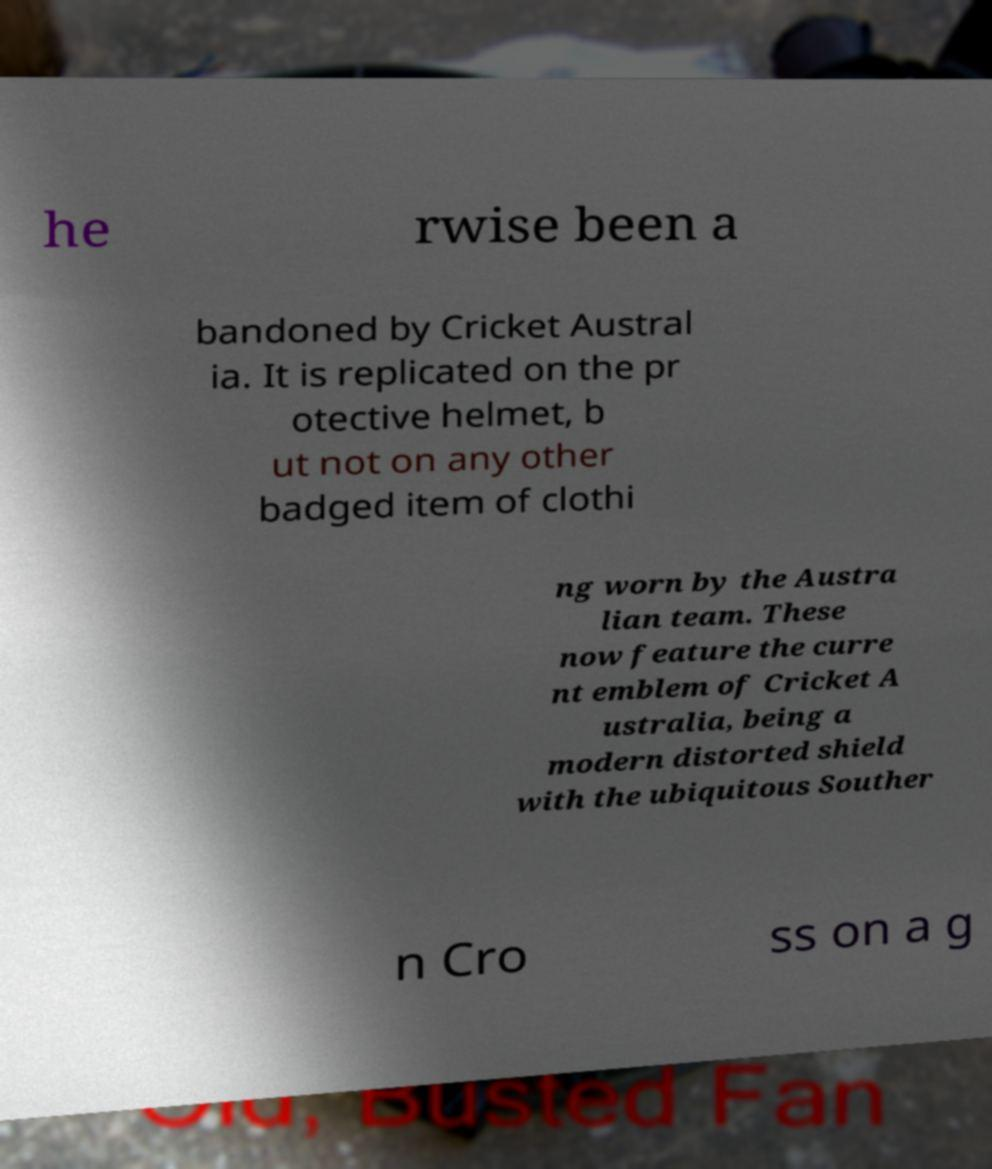Please identify and transcribe the text found in this image. he rwise been a bandoned by Cricket Austral ia. It is replicated on the pr otective helmet, b ut not on any other badged item of clothi ng worn by the Austra lian team. These now feature the curre nt emblem of Cricket A ustralia, being a modern distorted shield with the ubiquitous Souther n Cro ss on a g 